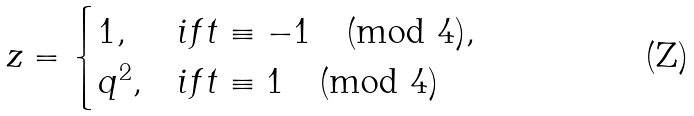Convert formula to latex. <formula><loc_0><loc_0><loc_500><loc_500>z = \begin{cases} 1 , & i f t \equiv - 1 \pmod { 4 } , \\ q ^ { 2 } , & i f t \equiv 1 \pmod { 4 } \end{cases}</formula> 